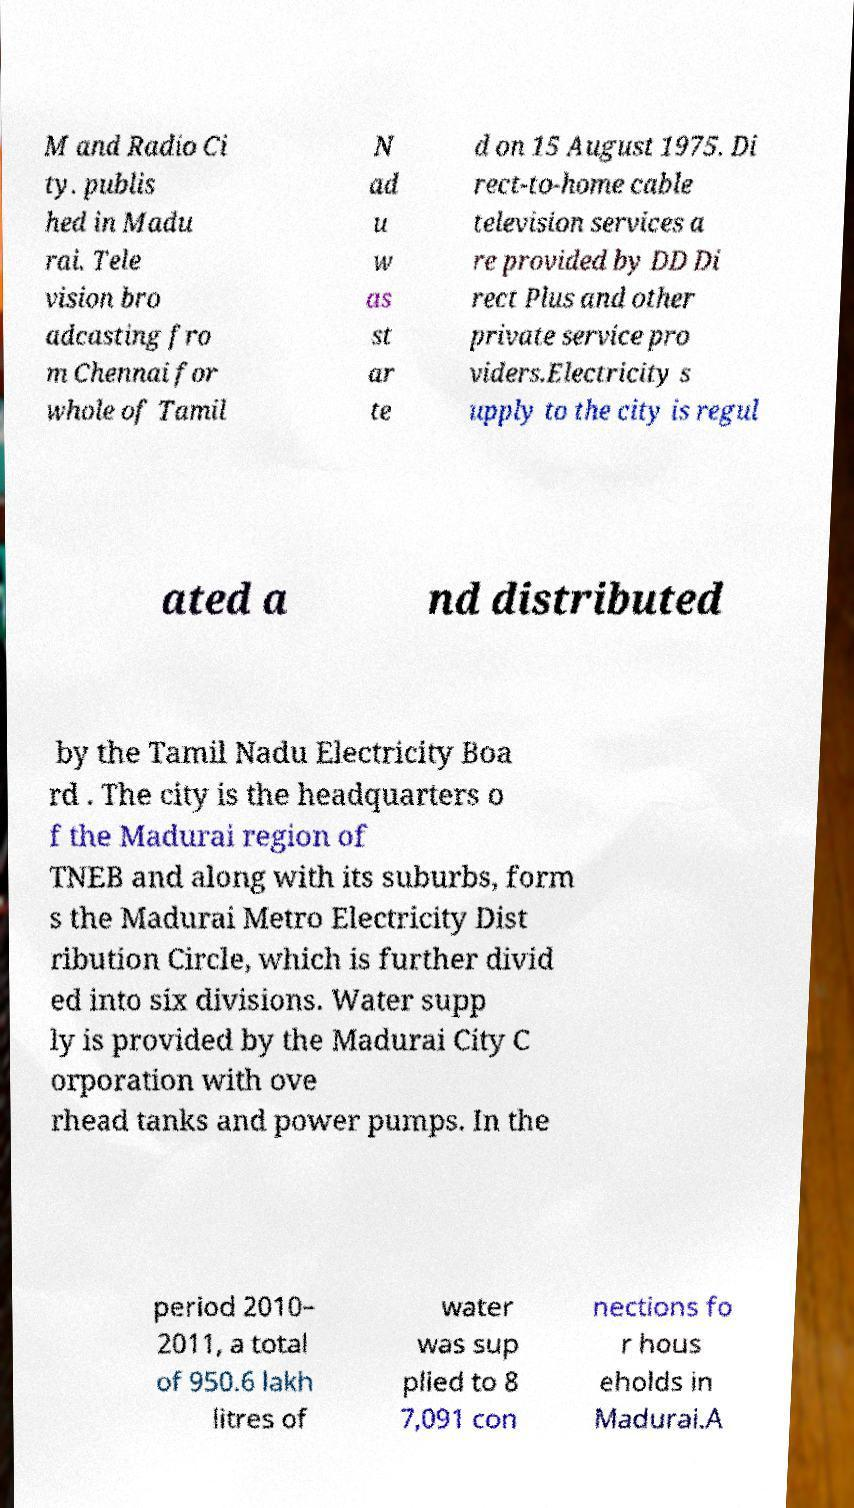For documentation purposes, I need the text within this image transcribed. Could you provide that? M and Radio Ci ty. publis hed in Madu rai. Tele vision bro adcasting fro m Chennai for whole of Tamil N ad u w as st ar te d on 15 August 1975. Di rect-to-home cable television services a re provided by DD Di rect Plus and other private service pro viders.Electricity s upply to the city is regul ated a nd distributed by the Tamil Nadu Electricity Boa rd . The city is the headquarters o f the Madurai region of TNEB and along with its suburbs, form s the Madurai Metro Electricity Dist ribution Circle, which is further divid ed into six divisions. Water supp ly is provided by the Madurai City C orporation with ove rhead tanks and power pumps. In the period 2010– 2011, a total of 950.6 lakh litres of water was sup plied to 8 7,091 con nections fo r hous eholds in Madurai.A 